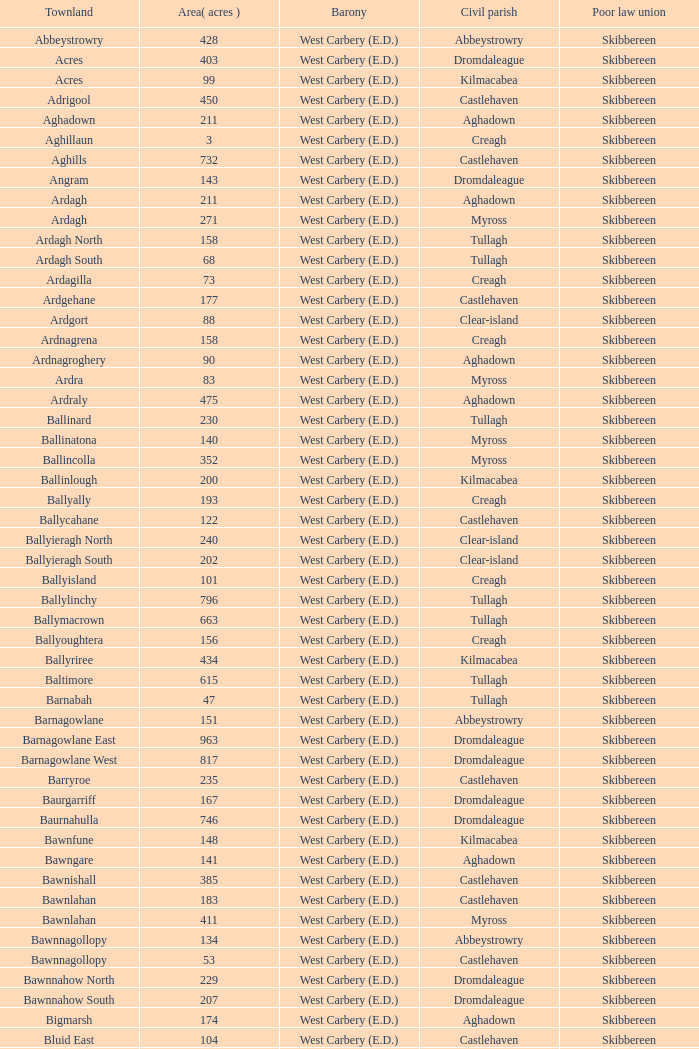In the loughmarsh townland, which civil parishes are present? Aghadown. 